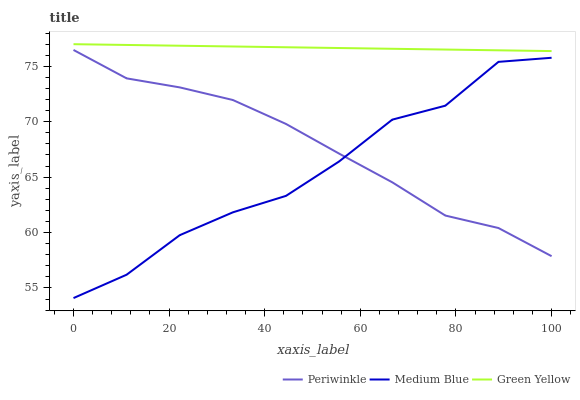Does Periwinkle have the minimum area under the curve?
Answer yes or no. No. Does Periwinkle have the maximum area under the curve?
Answer yes or no. No. Is Periwinkle the smoothest?
Answer yes or no. No. Is Periwinkle the roughest?
Answer yes or no. No. Does Periwinkle have the lowest value?
Answer yes or no. No. Does Periwinkle have the highest value?
Answer yes or no. No. Is Medium Blue less than Green Yellow?
Answer yes or no. Yes. Is Green Yellow greater than Medium Blue?
Answer yes or no. Yes. Does Medium Blue intersect Green Yellow?
Answer yes or no. No. 